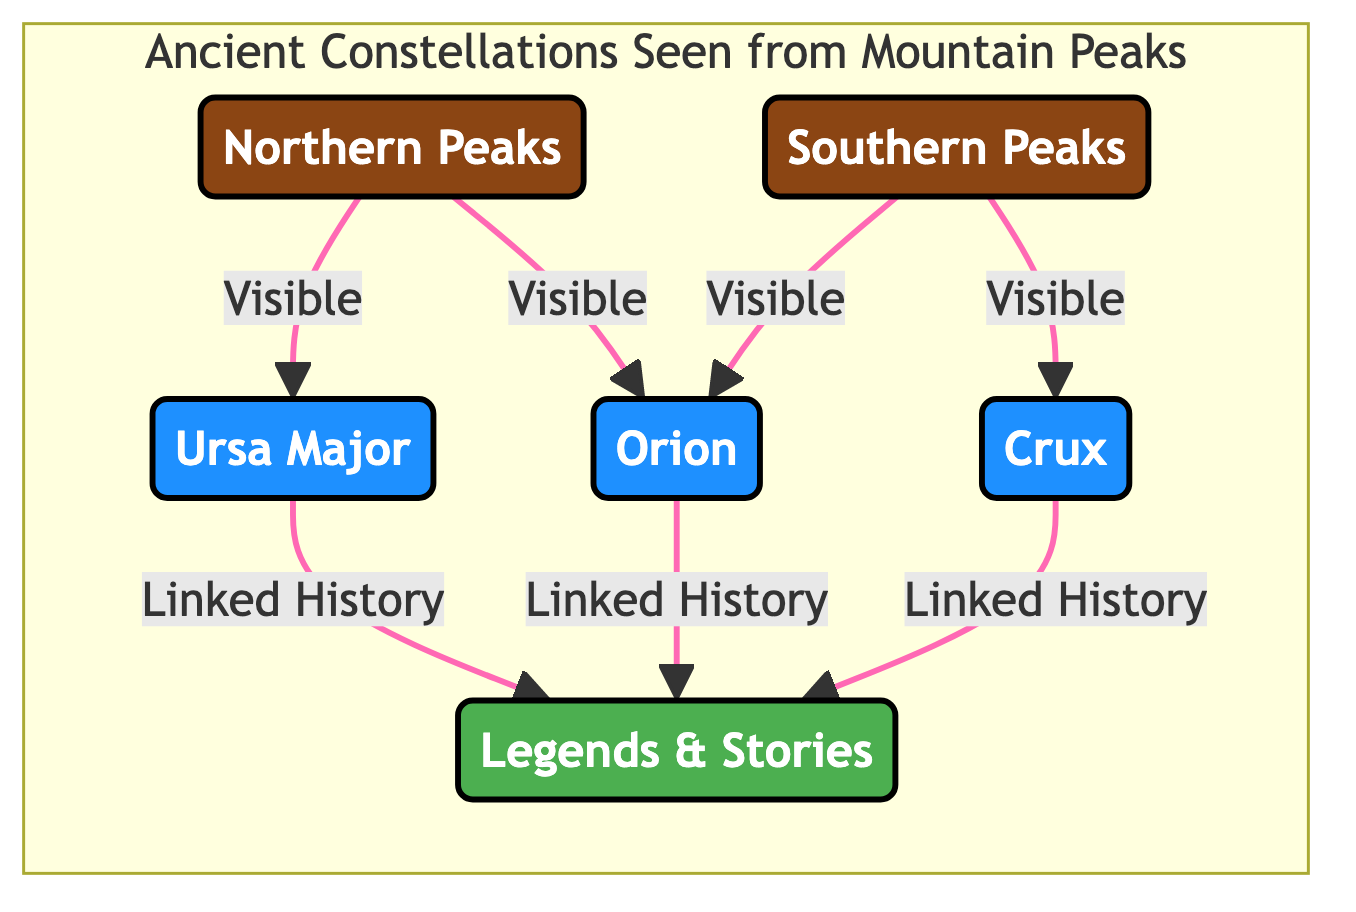What ancient constellation is linked to the legends and stories? The diagram flows from the constellations to the legends and stories, showing that both Ursa Major and Orion have linked histories with these narratives. Therefore, either Ursa Major or Orion can be an answer.
Answer: Ursa Major How many constellations are visible from the southern peaks? In the diagram, there are two constellations indicated as visible from the southern peaks: Orion and Crux. Therefore, the count of constellations visible is two.
Answer: 2 Which constellation is visible from both northern and southern peaks? By examining the diagram, Orion appears to connect to both the northern and southern peaks, indicating it is the only constellation visible from both.
Answer: Orion What are the two peak types shown in the diagram? The diagram labels two distinct types of peaks: Northern Peaks and Southern Peaks. Therefore, those are the only types explicitly mentioned.
Answer: Northern Peaks, Southern Peaks How many linked constellations show relationships to legends and stories? The diagram illustrates three constellations (Ursa Major, Orion, and Crux) linked to legends and stories, indicating their connection to cultural narratives. Thus, the total count is three.
Answer: 3 Which constellation is present only in the northern peaks? The diagram does not indicate any constellations visible only from the northern peaks as both Ursa Major and Orion are also visible from the south, while Crux is unique to the southern area. Therefore, there is no constellation exclusive to the northern peaks.
Answer: None Which peak type is associated with Crux? The diagram shows that Crux is only visible from the southern peaks, which directly associates it with that location.
Answer: Southern Peaks List all the constellations visible from the northern peaks. The diagram indicates that both Ursa Major and Orion are visible from the northern peaks, providing a straightforward list of these two constellations as the answer.
Answer: Ursa Major, Orion 